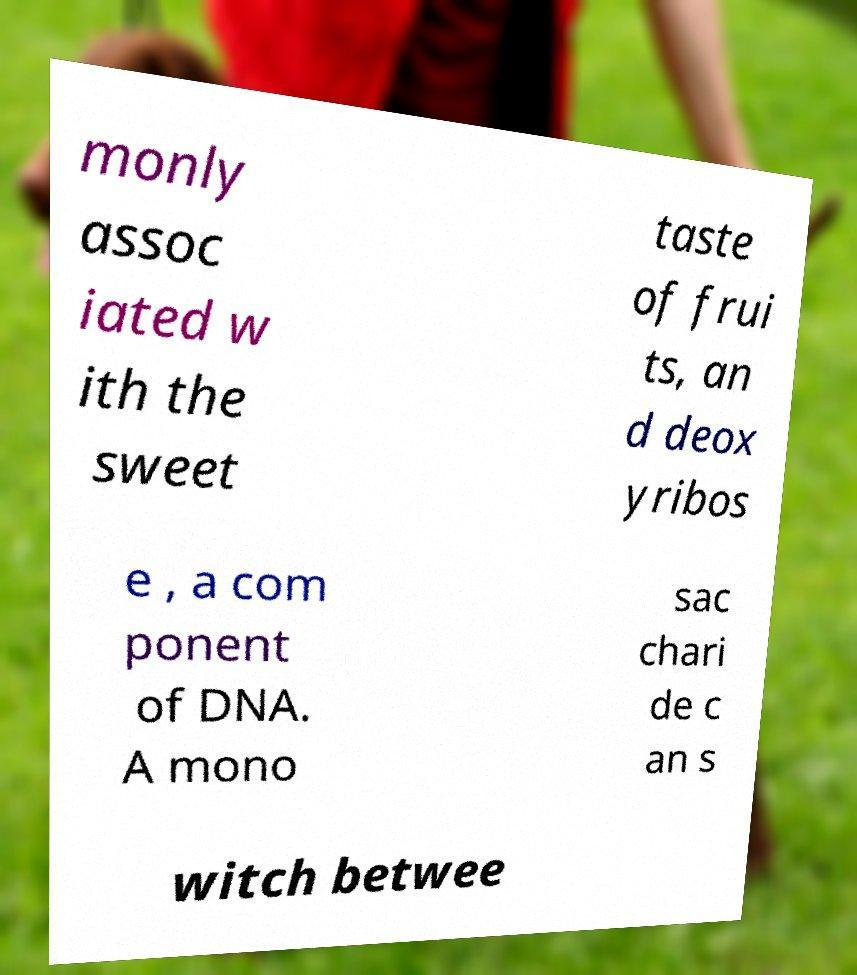There's text embedded in this image that I need extracted. Can you transcribe it verbatim? monly assoc iated w ith the sweet taste of frui ts, an d deox yribos e , a com ponent of DNA. A mono sac chari de c an s witch betwee 